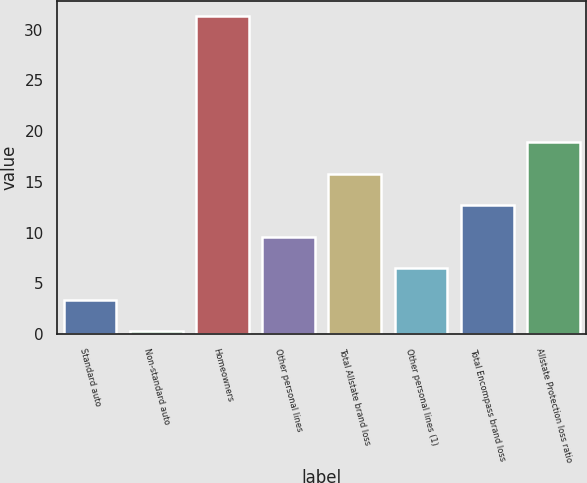Convert chart to OTSL. <chart><loc_0><loc_0><loc_500><loc_500><bar_chart><fcel>Standard auto<fcel>Non-standard auto<fcel>Homeowners<fcel>Other personal lines<fcel>Total Allstate brand loss<fcel>Other personal lines (1)<fcel>Total Encompass brand loss<fcel>Allstate Protection loss ratio<nl><fcel>3.4<fcel>0.3<fcel>31.3<fcel>9.6<fcel>15.8<fcel>6.5<fcel>12.7<fcel>18.9<nl></chart> 